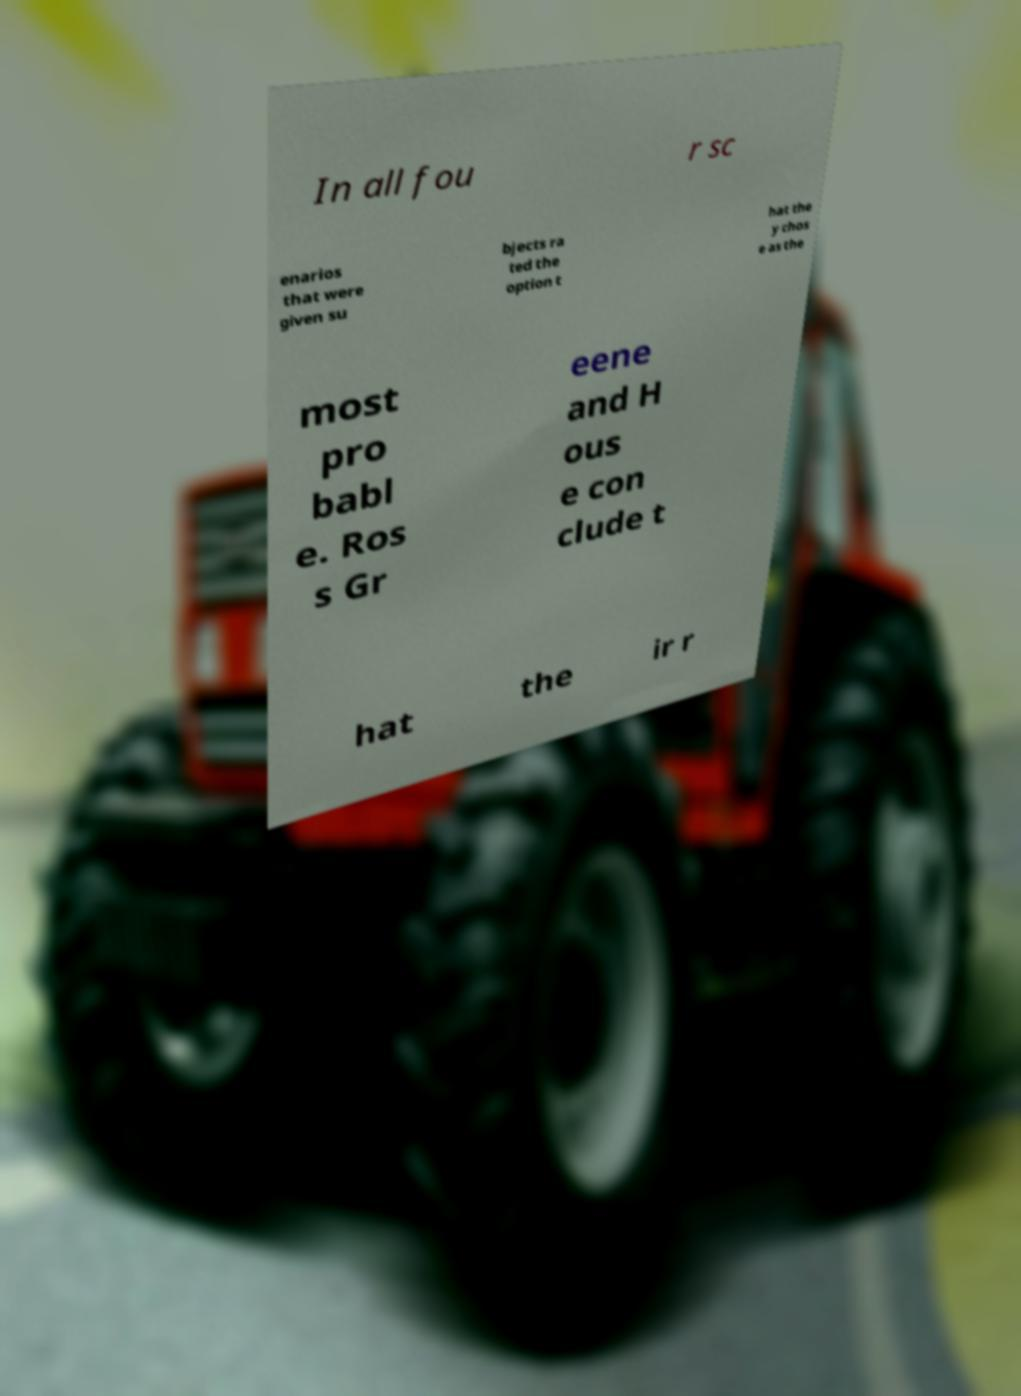Please identify and transcribe the text found in this image. In all fou r sc enarios that were given su bjects ra ted the option t hat the y chos e as the most pro babl e. Ros s Gr eene and H ous e con clude t hat the ir r 